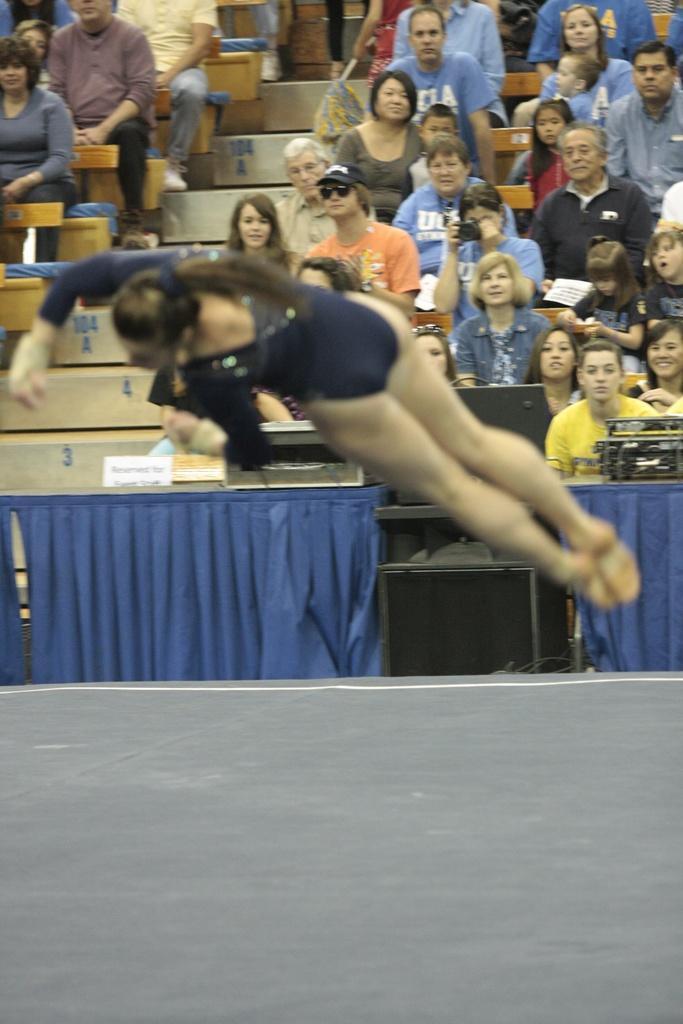How would you summarize this image in a sentence or two? In this image I see a woman who is in the air and I see the path over here and I see the blue color curtains. In the background I see number of people who are sitting and I see the steps over here. 